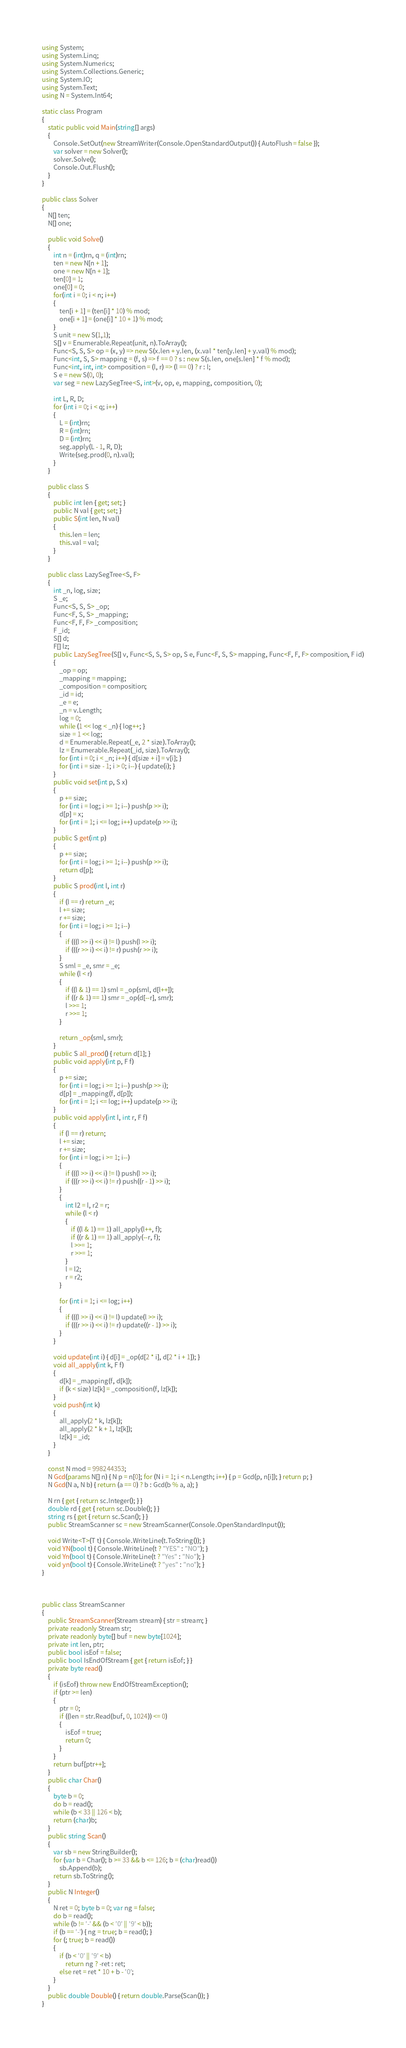<code> <loc_0><loc_0><loc_500><loc_500><_C#_>using System;
using System.Linq;
using System.Numerics;
using System.Collections.Generic;
using System.IO;
using System.Text;
using N = System.Int64;

static class Program
{
    static public void Main(string[] args)
    {
        Console.SetOut(new StreamWriter(Console.OpenStandardOutput()) { AutoFlush = false });
        var solver = new Solver();
        solver.Solve();
        Console.Out.Flush();
    }
}

public class Solver
{
    N[] ten;
    N[] one;

    public void Solve()
    {
        int n = (int)rn, q = (int)rn;
        ten = new N[n + 1];
        one = new N[n + 1];
        ten[0] = 1;
        one[0] = 0;
        for(int i = 0; i < n; i++)
        {
            ten[i + 1] = (ten[i] * 10) % mod;
            one[i + 1] = (one[i] * 10 + 1) % mod;
        }
        S unit = new S(1,1);
        S[] v = Enumerable.Repeat(unit, n).ToArray();
        Func<S, S, S> op = (x, y) => new S(x.len + y.len, (x.val * ten[y.len] + y.val) % mod);
        Func<int, S, S> mapping = (f, s) => f == 0 ? s : new S(s.len, one[s.len] * f % mod);
        Func<int, int, int> composition = (l, r) => (l == 0) ? r : l;
        S e = new S(0, 0);
        var seg = new LazySegTree<S, int>(v, op, e, mapping, composition, 0);

        int L, R, D;
        for (int i = 0; i < q; i++)
        {
            L = (int)rn;
            R = (int)rn;
            D = (int)rn;
            seg.apply(L - 1, R, D);
            Write(seg.prod(0, n).val);
        }
    }

    public class S
    {
        public int len { get; set; }
        public N val { get; set; }
        public S(int len, N val)
        {
            this.len = len;
            this.val = val;
        }
    }

    public class LazySegTree<S, F>
    {
        int _n, log, size;
        S _e;
        Func<S, S, S> _op;
        Func<F, S, S> _mapping;
        Func<F, F, F> _composition;
        F _id;
        S[] d;
        F[] lz;
        public LazySegTree(S[] v, Func<S, S, S> op, S e, Func<F, S, S> mapping, Func<F, F, F> composition, F id)
        {
            _op = op;
            _mapping = mapping;
            _composition = composition;
            _id = id;
            _e = e;
            _n = v.Length;
            log = 0;
            while (1 << log < _n) { log++; }
            size = 1 << log;
            d = Enumerable.Repeat(_e, 2 * size).ToArray();
            lz = Enumerable.Repeat(_id, size).ToArray();
            for (int i = 0; i < _n; i++) { d[size + i] = v[i]; }
            for (int i = size - 1; i > 0; i--) { update(i); }
        }
        public void set(int p, S x)
        {
            p += size;
            for (int i = log; i >= 1; i--) push(p >> i);
            d[p] = x;
            for (int i = 1; i <= log; i++) update(p >> i);
        }
        public S get(int p)
        {
            p += size;
            for (int i = log; i >= 1; i--) push(p >> i);
            return d[p];
        }
        public S prod(int l, int r)
        {
            if (l == r) return _e;
            l += size;
            r += size;
            for (int i = log; i >= 1; i--)
            {
                if (((l >> i) << i) != l) push(l >> i);
                if (((r >> i) << i) != r) push(r >> i);
            }
            S sml = _e, smr = _e;
            while (l < r)
            {
                if ((l & 1) == 1) sml = _op(sml, d[l++]);
                if ((r & 1) == 1) smr = _op(d[--r], smr);
                l >>= 1;
                r >>= 1;
            }

            return _op(sml, smr);
        }
        public S all_prod() { return d[1]; }
        public void apply(int p, F f)
        {
            p += size;
            for (int i = log; i >= 1; i--) push(p >> i);
            d[p] = _mapping(f, d[p]);
            for (int i = 1; i <= log; i++) update(p >> i);
        }
        public void apply(int l, int r, F f)
        {
            if (l == r) return;
            l += size;
            r += size;
            for (int i = log; i >= 1; i--)
            {
                if (((l >> i) << i) != l) push(l >> i);
                if (((r >> i) << i) != r) push((r - 1) >> i);
            }
            {
                int l2 = l, r2 = r;
                while (l < r)
                {
                    if ((l & 1) == 1) all_apply(l++, f);
                    if ((r & 1) == 1) all_apply(--r, f);
                    l >>= 1;
                    r >>= 1;
                }
                l = l2;
                r = r2;
            }

            for (int i = 1; i <= log; i++)
            {
                if (((l >> i) << i) != l) update(l >> i);
                if (((r >> i) << i) != r) update((r - 1) >> i);
            }
        }

        void update(int i) { d[i] = _op(d[2 * i], d[2 * i + 1]); }
        void all_apply(int k, F f)
        {
            d[k] = _mapping(f, d[k]);
            if (k < size) lz[k] = _composition(f, lz[k]);
        }
        void push(int k)
        {
            all_apply(2 * k, lz[k]);
            all_apply(2 * k + 1, lz[k]);
            lz[k] = _id;
        }
    }

    const N mod = 998244353;
    N Gcd(params N[] n) { N p = n[0]; for (N i = 1; i < n.Length; i++) { p = Gcd(p, n[i]); } return p; }
    N Gcd(N a, N b) { return (a == 0) ? b : Gcd(b % a, a); }

    N rn { get { return sc.Integer(); } }
    double rd { get { return sc.Double(); } }
    string rs { get { return sc.Scan(); } }
    public StreamScanner sc = new StreamScanner(Console.OpenStandardInput());

    void Write<T>(T t) { Console.WriteLine(t.ToString()); }
    void YN(bool t) { Console.WriteLine(t ? "YES" : "NO"); }
    void Yn(bool t) { Console.WriteLine(t ? "Yes" : "No"); }
    void yn(bool t) { Console.WriteLine(t ? "yes" : "no"); }
}



public class StreamScanner
{
    public StreamScanner(Stream stream) { str = stream; }
    private readonly Stream str;
    private readonly byte[] buf = new byte[1024];
    private int len, ptr;
    public bool isEof = false;
    public bool IsEndOfStream { get { return isEof; } }
    private byte read()
    {
        if (isEof) throw new EndOfStreamException();
        if (ptr >= len)
        {
            ptr = 0;
            if ((len = str.Read(buf, 0, 1024)) <= 0)
            {
                isEof = true;
                return 0;
            }
        }
        return buf[ptr++];
    }
    public char Char()
    {
        byte b = 0;
        do b = read();
        while (b < 33 || 126 < b);
        return (char)b;
    }
    public string Scan()
    {
        var sb = new StringBuilder();
        for (var b = Char(); b >= 33 && b <= 126; b = (char)read())
            sb.Append(b);
        return sb.ToString();
    }
    public N Integer()
    {
        N ret = 0; byte b = 0; var ng = false;
        do b = read();
        while (b != '-' && (b < '0' || '9' < b));
        if (b == '-') { ng = true; b = read(); }
        for (; true; b = read())
        {
            if (b < '0' || '9' < b)
                return ng ? -ret : ret;
            else ret = ret * 10 + b - '0';
        }
    }
    public double Double() { return double.Parse(Scan()); }
}
</code> 